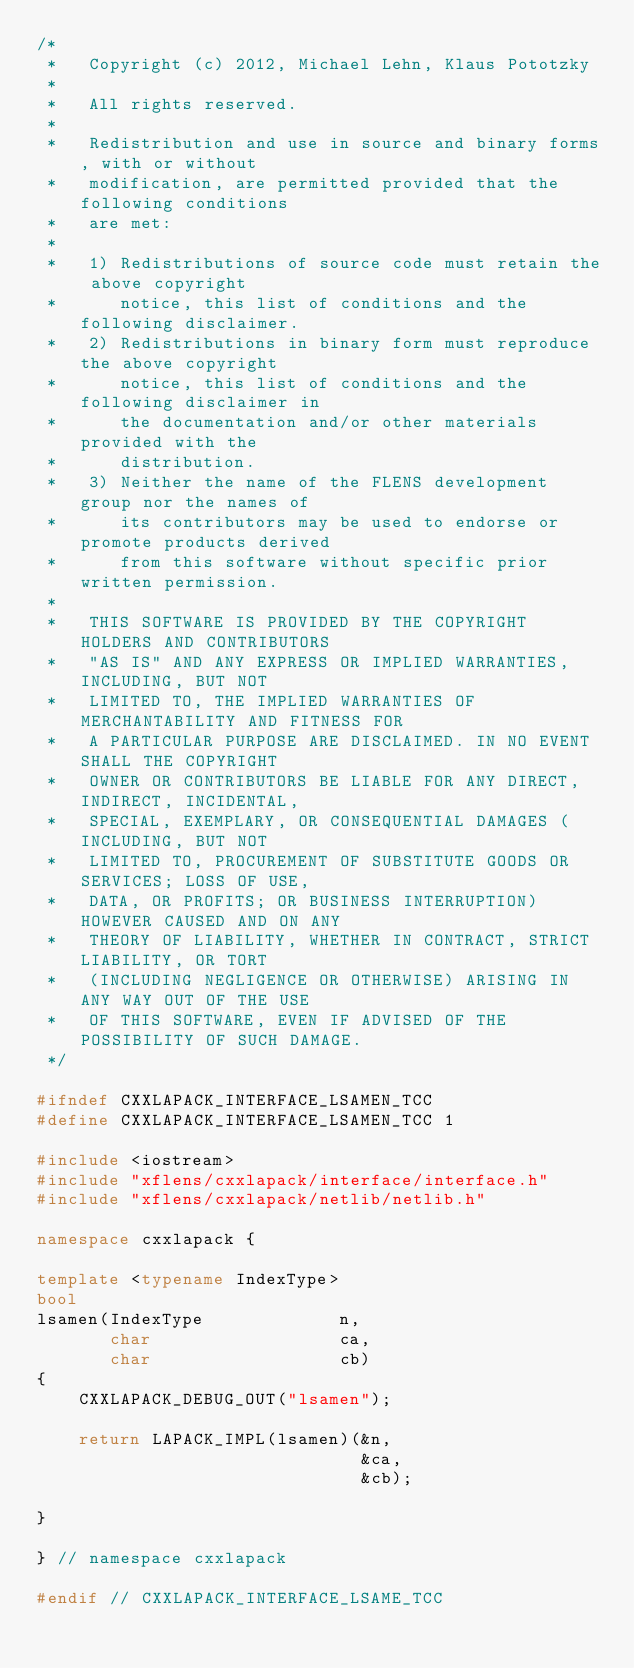Convert code to text. <code><loc_0><loc_0><loc_500><loc_500><_C++_>/*
 *   Copyright (c) 2012, Michael Lehn, Klaus Pototzky
 *
 *   All rights reserved.
 *
 *   Redistribution and use in source and binary forms, with or without
 *   modification, are permitted provided that the following conditions
 *   are met:
 *
 *   1) Redistributions of source code must retain the above copyright
 *      notice, this list of conditions and the following disclaimer.
 *   2) Redistributions in binary form must reproduce the above copyright
 *      notice, this list of conditions and the following disclaimer in
 *      the documentation and/or other materials provided with the
 *      distribution.
 *   3) Neither the name of the FLENS development group nor the names of
 *      its contributors may be used to endorse or promote products derived
 *      from this software without specific prior written permission.
 *
 *   THIS SOFTWARE IS PROVIDED BY THE COPYRIGHT HOLDERS AND CONTRIBUTORS
 *   "AS IS" AND ANY EXPRESS OR IMPLIED WARRANTIES, INCLUDING, BUT NOT
 *   LIMITED TO, THE IMPLIED WARRANTIES OF MERCHANTABILITY AND FITNESS FOR
 *   A PARTICULAR PURPOSE ARE DISCLAIMED. IN NO EVENT SHALL THE COPYRIGHT
 *   OWNER OR CONTRIBUTORS BE LIABLE FOR ANY DIRECT, INDIRECT, INCIDENTAL,
 *   SPECIAL, EXEMPLARY, OR CONSEQUENTIAL DAMAGES (INCLUDING, BUT NOT
 *   LIMITED TO, PROCUREMENT OF SUBSTITUTE GOODS OR SERVICES; LOSS OF USE,
 *   DATA, OR PROFITS; OR BUSINESS INTERRUPTION) HOWEVER CAUSED AND ON ANY
 *   THEORY OF LIABILITY, WHETHER IN CONTRACT, STRICT LIABILITY, OR TORT
 *   (INCLUDING NEGLIGENCE OR OTHERWISE) ARISING IN ANY WAY OUT OF THE USE
 *   OF THIS SOFTWARE, EVEN IF ADVISED OF THE POSSIBILITY OF SUCH DAMAGE.
 */

#ifndef CXXLAPACK_INTERFACE_LSAMEN_TCC
#define CXXLAPACK_INTERFACE_LSAMEN_TCC 1

#include <iostream>
#include "xflens/cxxlapack/interface/interface.h"
#include "xflens/cxxlapack/netlib/netlib.h"

namespace cxxlapack {

template <typename IndexType>
bool
lsamen(IndexType             n,
       char                  ca,
       char                  cb)
{
    CXXLAPACK_DEBUG_OUT("lsamen");

    return LAPACK_IMPL(lsamen)(&n,
                               &ca,
                               &cb);

}

} // namespace cxxlapack

#endif // CXXLAPACK_INTERFACE_LSAME_TCC
</code> 